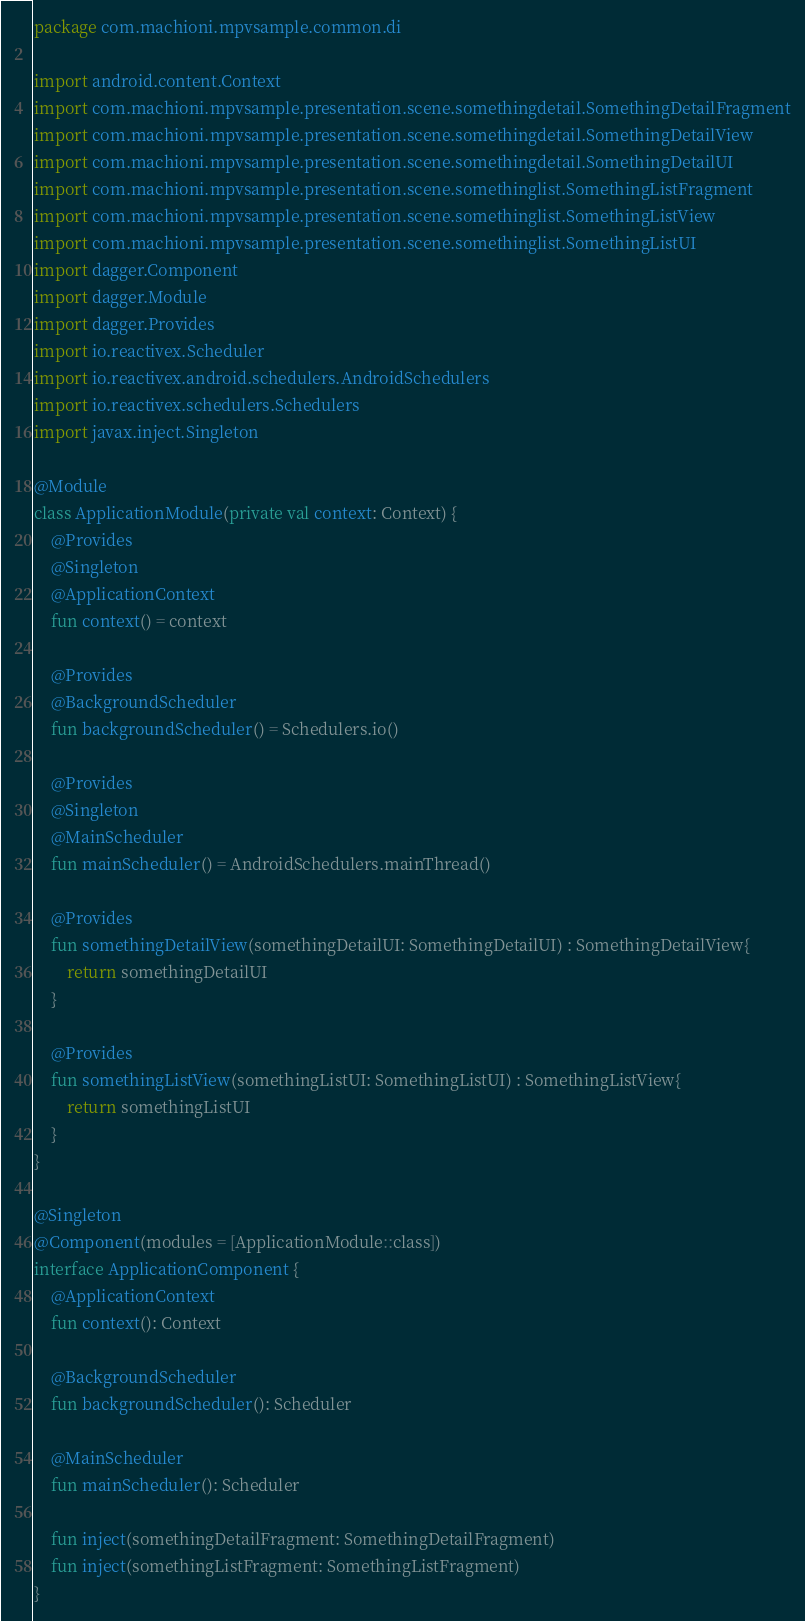<code> <loc_0><loc_0><loc_500><loc_500><_Kotlin_>package com.machioni.mpvsample.common.di

import android.content.Context
import com.machioni.mpvsample.presentation.scene.somethingdetail.SomethingDetailFragment
import com.machioni.mpvsample.presentation.scene.somethingdetail.SomethingDetailView
import com.machioni.mpvsample.presentation.scene.somethingdetail.SomethingDetailUI
import com.machioni.mpvsample.presentation.scene.somethinglist.SomethingListFragment
import com.machioni.mpvsample.presentation.scene.somethinglist.SomethingListView
import com.machioni.mpvsample.presentation.scene.somethinglist.SomethingListUI
import dagger.Component
import dagger.Module
import dagger.Provides
import io.reactivex.Scheduler
import io.reactivex.android.schedulers.AndroidSchedulers
import io.reactivex.schedulers.Schedulers
import javax.inject.Singleton

@Module
class ApplicationModule(private val context: Context) {
    @Provides
    @Singleton
    @ApplicationContext
    fun context() = context

    @Provides
    @BackgroundScheduler
    fun backgroundScheduler() = Schedulers.io()

    @Provides
    @Singleton
    @MainScheduler
    fun mainScheduler() = AndroidSchedulers.mainThread()

    @Provides
    fun somethingDetailView(somethingDetailUI: SomethingDetailUI) : SomethingDetailView{
        return somethingDetailUI
    }

    @Provides
    fun somethingListView(somethingListUI: SomethingListUI) : SomethingListView{
        return somethingListUI
    }
}

@Singleton
@Component(modules = [ApplicationModule::class])
interface ApplicationComponent {
    @ApplicationContext
    fun context(): Context

    @BackgroundScheduler
    fun backgroundScheduler(): Scheduler

    @MainScheduler
    fun mainScheduler(): Scheduler

    fun inject(somethingDetailFragment: SomethingDetailFragment)
    fun inject(somethingListFragment: SomethingListFragment)
}</code> 